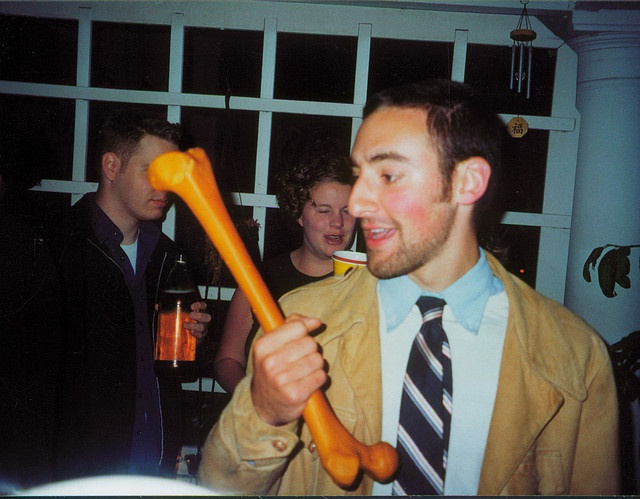Describe the objects in this image and their specific colors. I can see people in gray, tan, black, and lightblue tones, people in gray, black, brown, and maroon tones, people in gray, black, brown, and maroon tones, tie in gray, black, and darkgray tones, and bottle in gray, black, brown, and maroon tones in this image. 